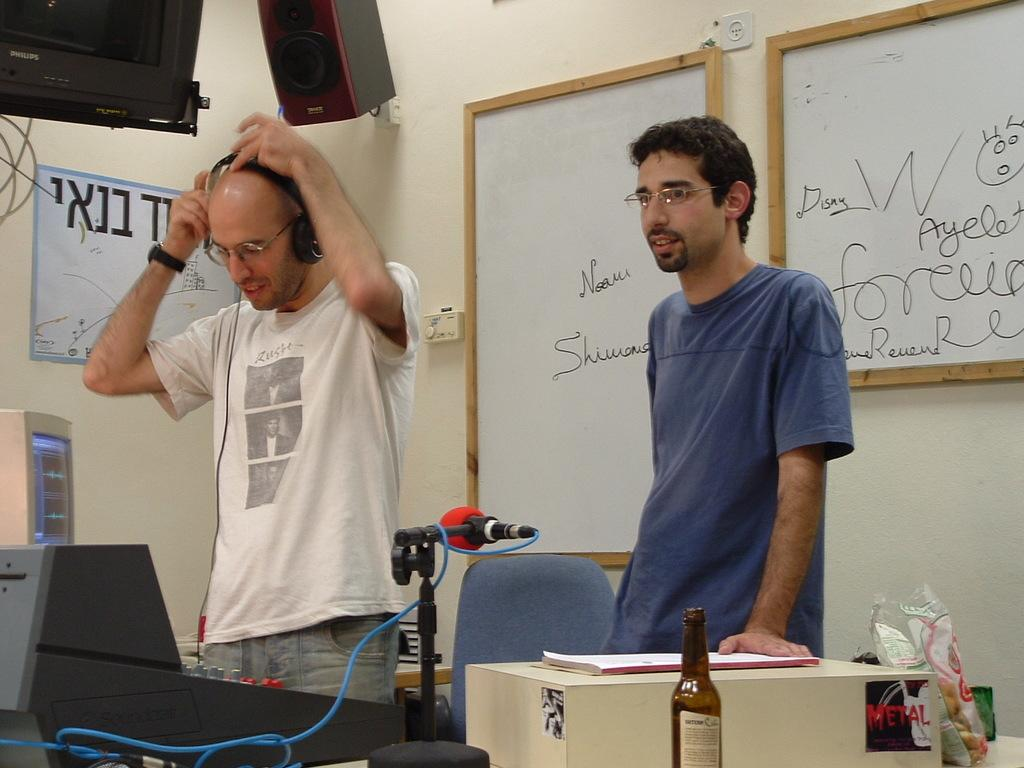<image>
Summarize the visual content of the image. Two men standing in front of a board that says NOAM on it. 